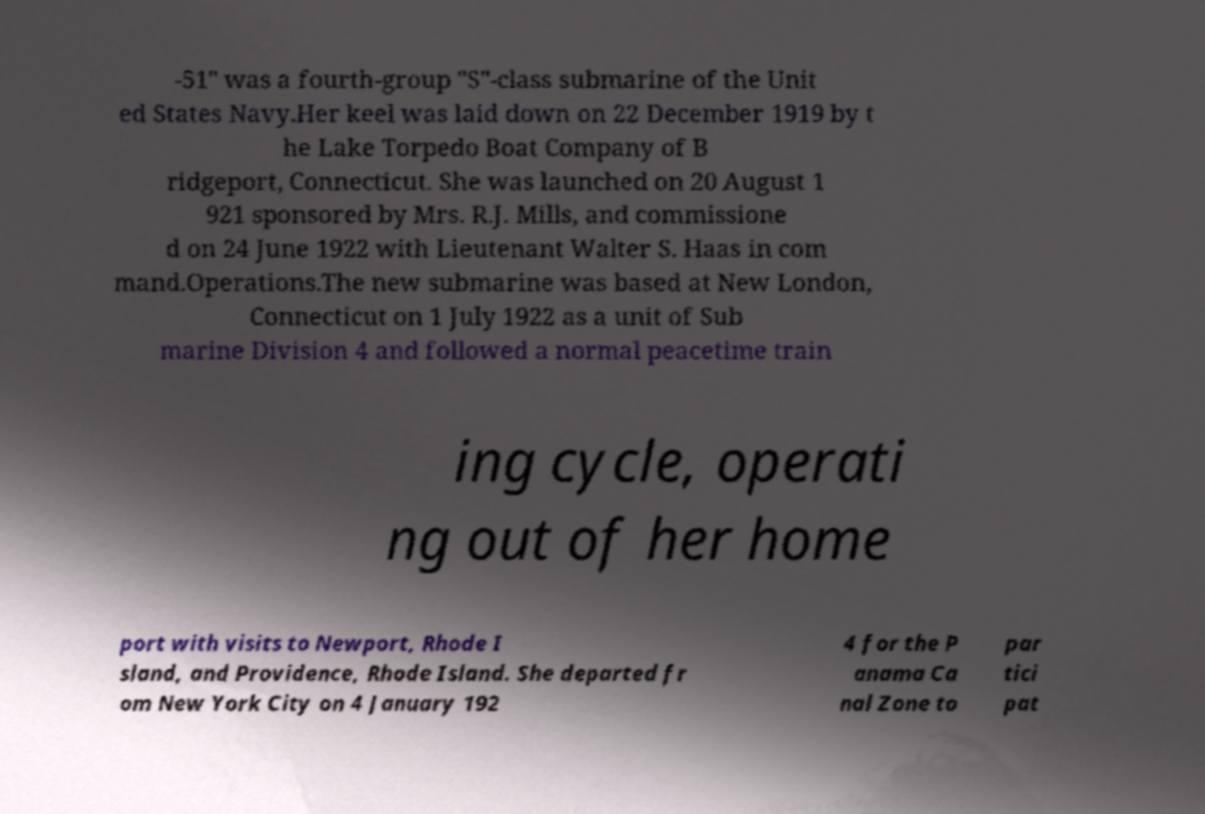What messages or text are displayed in this image? I need them in a readable, typed format. -51" was a fourth-group "S"-class submarine of the Unit ed States Navy.Her keel was laid down on 22 December 1919 by t he Lake Torpedo Boat Company of B ridgeport, Connecticut. She was launched on 20 August 1 921 sponsored by Mrs. R.J. Mills, and commissione d on 24 June 1922 with Lieutenant Walter S. Haas in com mand.Operations.The new submarine was based at New London, Connecticut on 1 July 1922 as a unit of Sub marine Division 4 and followed a normal peacetime train ing cycle, operati ng out of her home port with visits to Newport, Rhode I sland, and Providence, Rhode Island. She departed fr om New York City on 4 January 192 4 for the P anama Ca nal Zone to par tici pat 